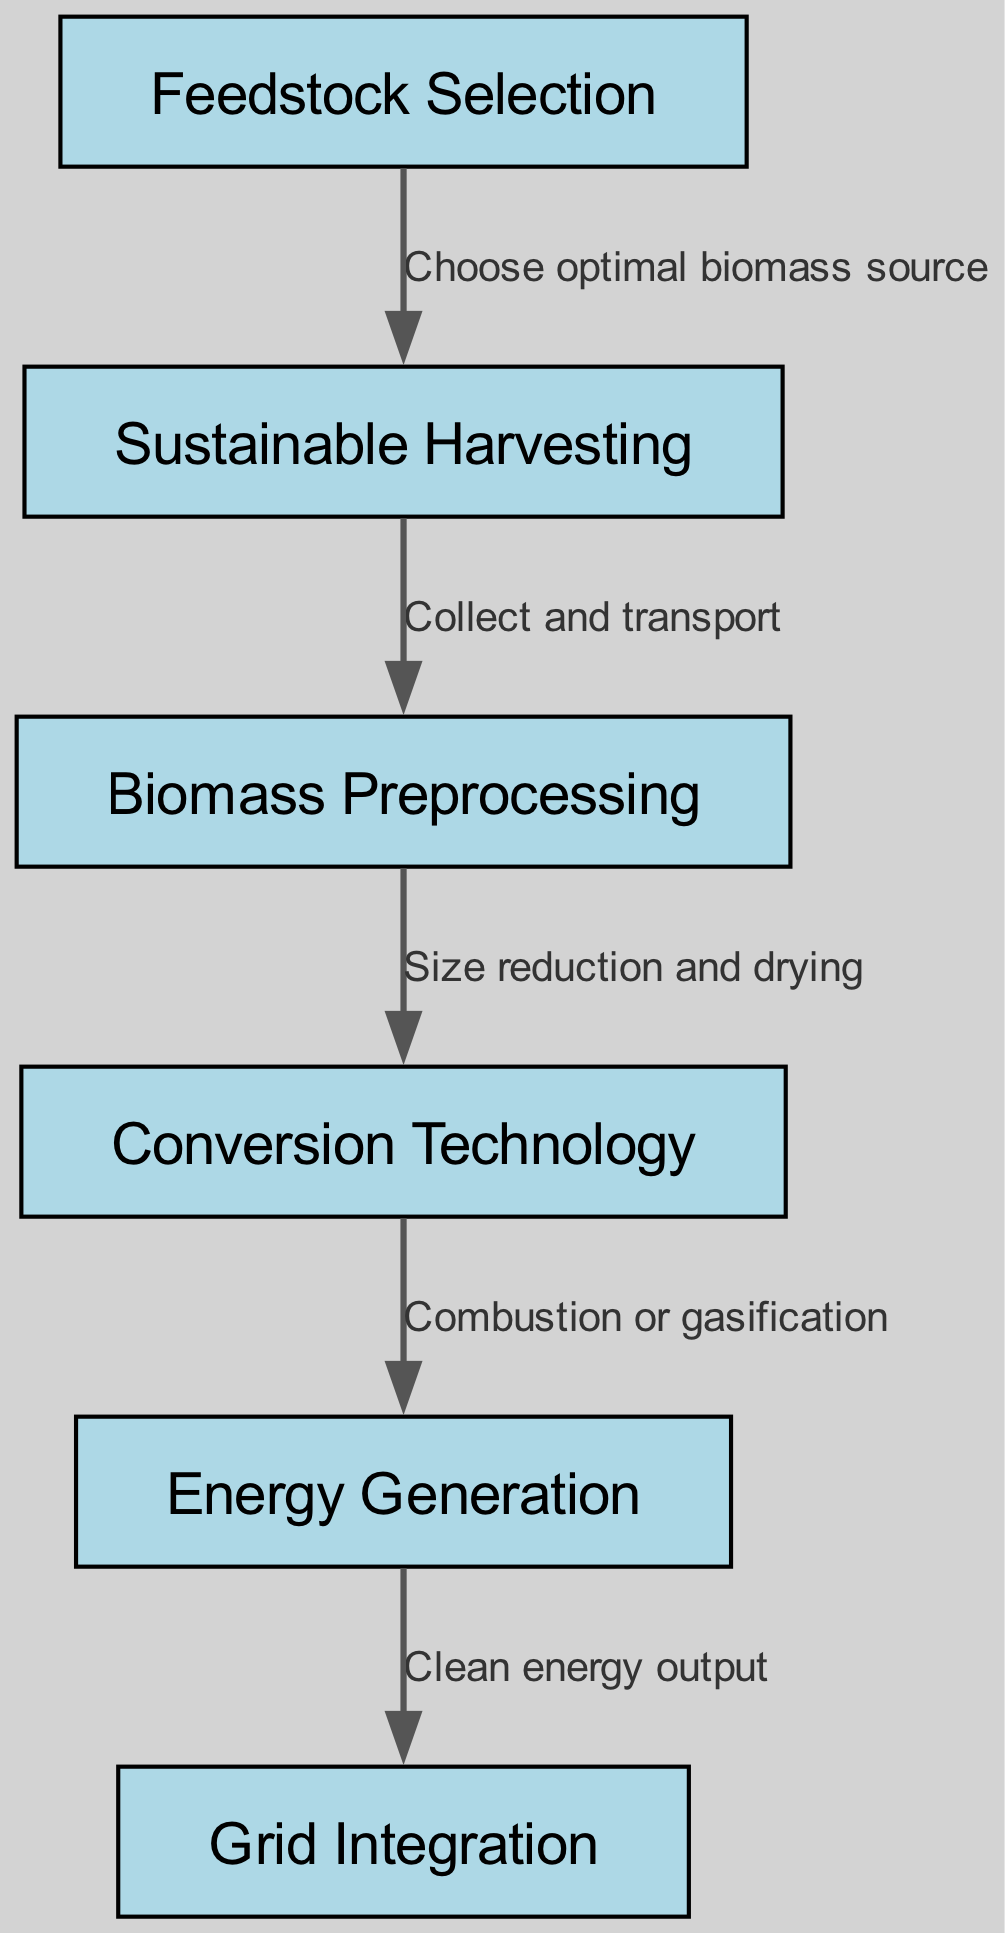What is the first step in the biomass energy production workflow? The diagram indicates "Feedstock Selection" as the starting point in the workflow. This is the node that initiates the process, leading to sustainable harvesting.
Answer: Feedstock Selection How many nodes are there in the diagram? By counting each unique step or component represented in the diagram, we see there are six nodes: Feedstock Selection, Sustainable Harvesting, Biomass Preprocessing, Conversion Technology, Energy Generation, and Grid Integration.
Answer: Six What is the relationship between "Biomass Preprocessing" and "Conversion Technology"? The edge connecting "Biomass Preprocessing" to "Conversion Technology" indicates the process involving size reduction and drying. This relationship shows how preprocessing leads to the next step in the workflow.
Answer: Size reduction and drying What is the clean energy output step also known as? The node "Energy Generation" is the step that produces clean energy output, demonstrating its role in the diagram. Therefore, it is synonymous with energy generation in this context.
Answer: Energy Generation Which step involves the collection and transportation of biomass? The edge leading from "Sustainable Harvesting" to "Biomass Preprocessing" describes the action of collecting and transporting biomass, highlighting its role in the workflow.
Answer: Collect and transport What is the final step in the biomass energy workflow? The diagram shows "Grid Integration" as the last node, indicating that after generating energy, it needs to be integrated into the grid for use.
Answer: Grid Integration What do "Combustion or gasification" refer to in the diagram? "Combustion or gasification" is mentioned on the edge that connects "Conversion Technology" to "Energy Generation"; it describes the methods of converting biomass into energy.
Answer: Combustion or gasification What is the main purpose of the "Feedstock Selection" step? The primary goal indicated in the diagram is to choose the optimal biomass source for the entire energy production process, setting the foundation for subsequent steps.
Answer: Choose optimal biomass source 